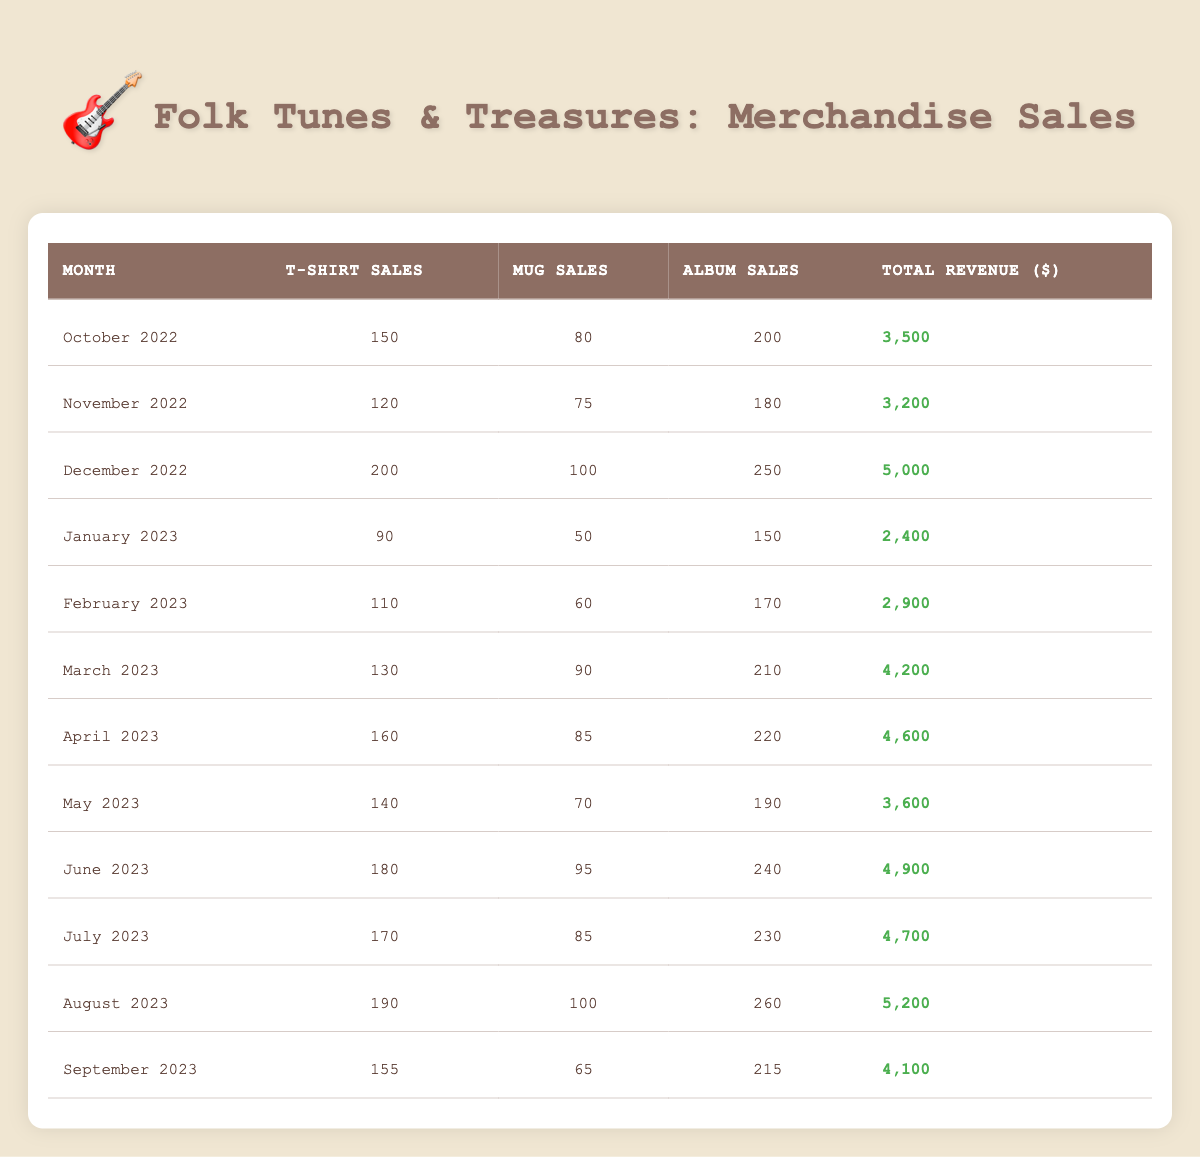What was the total revenue in December 2022? By looking at the table, I can see that the total revenue for December 2022 is indicated under the 'Total Revenue' column. It states that the revenue for that month was 5000.
Answer: 5000 How many t-shirts were sold in May 2023? From the table, the number of t-shirts sold in May 2023 is listed in the 'T-Shirt Sales' column, which shows a value of 140.
Answer: 140 What is the average total revenue across all months? To find the average total revenue, I will sum the total revenue values (3500 + 3200 + 5000 + 2400 + 2900 + 4200 + 4600 + 3600 + 4900 + 4700 + 5200 + 4100) which equals  47500, and divide that by the number of months (12). So, 47500 / 12 = 3958.33, rounded to two decimal places it is approximately 3958.33.
Answer: 3958.33 Did merchandise sales peak in August 2023? I can check the 'Total Revenue' for each month to see which month had the highest value. For August 2023, the total revenue is 5200, which is greater than all previous months. Therefore, merchandise sales indeed peaked in August 2023.
Answer: Yes What is the difference in total revenue between December 2022 and January 2023? The total revenue for December 2022 is 5000 and for January 2023 is 2400. To find the difference, I subtract January's revenue from December's revenue: 5000 - 2400 = 2600.
Answer: 2600 Which month had the highest album sales? I need to look at the 'Album Sales' column for each month and find the maximum value. December 2022 shows 250 album sales, which is the highest compared to other months.
Answer: December 2022 How many mugs were sold in the months where total revenue exceeded 4000? I will look at months with total revenue greater than 4000, which are December 2022, March 2023, April 2023, June 2023, July 2023, and August 2023. I'll add the mug sales from those months: 100 + 90 + 85 + 95 + 85 + 100 = 585.
Answer: 585 What was the total number of album sales over the last 12 months? To find the total number of album sales, I will sum the album sales from each month: (200 + 180 + 250 + 150 + 170 + 210 + 220 + 190 + 240 + 230 + 260 + 215) = 2,675.
Answer: 2675 Was the total revenue higher in April 2023 than in May 2023? By comparing the total revenue values, April 2023 shows a total revenue of 4600, while May 2023 shows 3600. Since 4600 is greater than 3600, the total revenue was indeed higher in April 2023.
Answer: Yes 